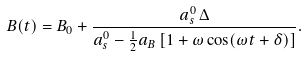<formula> <loc_0><loc_0><loc_500><loc_500>B ( t ) = B _ { 0 } + \frac { a _ { s } ^ { 0 } \, \Delta } { a _ { s } ^ { 0 } - \frac { 1 } { 2 } a _ { B } \left [ 1 + \omega \cos ( \omega t + \delta ) \right ] } .</formula> 